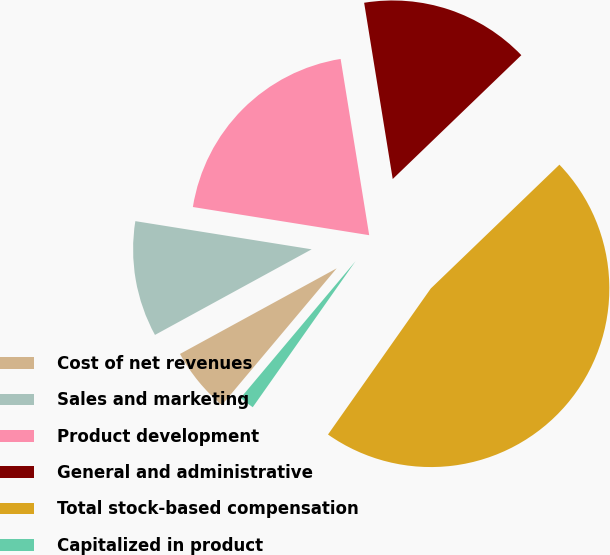<chart> <loc_0><loc_0><loc_500><loc_500><pie_chart><fcel>Cost of net revenues<fcel>Sales and marketing<fcel>Product development<fcel>General and administrative<fcel>Total stock-based compensation<fcel>Capitalized in product<nl><fcel>5.92%<fcel>10.48%<fcel>19.92%<fcel>15.36%<fcel>46.96%<fcel>1.36%<nl></chart> 